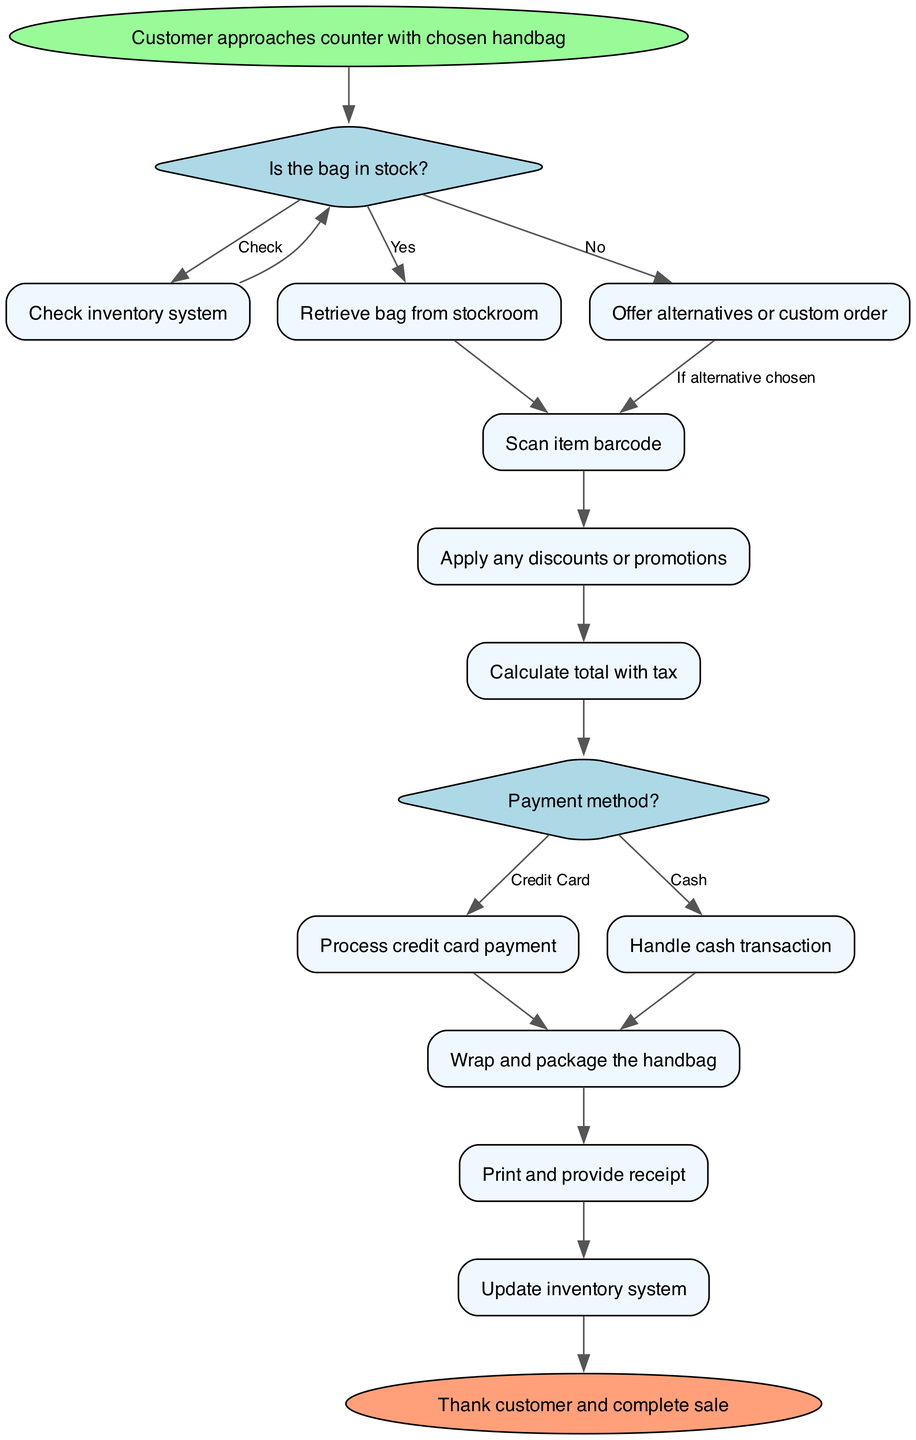What is the first step in the sales workflow? The workflow starts with the node labeled "Customer approaches counter with chosen handbag," indicating that the process begins with this action.
Answer: Customer approaches counter with chosen handbag How many decision nodes are there in the diagram? The diagram contains two decision nodes: "Is the bag in stock?" and "Payment method?" This can be counted directly from the diagram.
Answer: 2 What happens if the bag is not in stock? If the bag is not in stock, the flow leads to the process labeled "Offer alternatives or custom order," indicating that alternatives will be presented to the customer.
Answer: Offer alternatives or custom order What is the immediate action after calculating the total with tax? After calculating the total with tax, the next action is to decide on the payment method, as represented by the decision node "Payment method?" which follows the calculation step.
Answer: Payment method? What is the last process before the sale is completed? The final process before completing the sale is "Update inventory system," which comes right before the end node in the flowchart.
Answer: Update inventory system If the customer pays with a credit card, what is the following step? If the customer chooses to pay with a credit card, the workflow proceeds to "Process credit card payment," as indicated by the flow that follows from the decision node regarding payment method.
Answer: Process credit card payment What do we do after wrapping and packaging the handbag? After wrapping and packaging the handbag, the next step is to "Print and provide receipt," as seen further down the workflow from the wrapping process.
Answer: Print and provide receipt What action is taken if the customer wants an alternative handbag? If the customer opts for an alternative handbag, the flow directs to "Scan item barcode," which signifies the transition to processing the selected item.
Answer: Scan item barcode How do we verify if the handbag is available? We verify if the handbag is available by checking inventory through the process labeled "Check inventory system," which is the first action following the initial decision point.
Answer: Check inventory system 